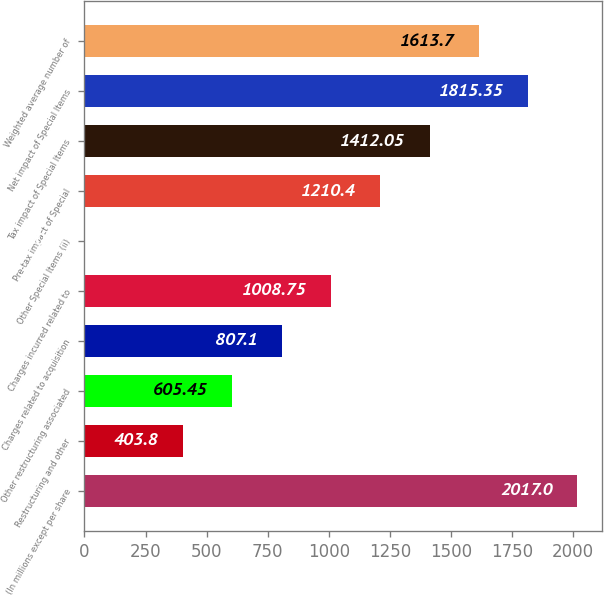Convert chart. <chart><loc_0><loc_0><loc_500><loc_500><bar_chart><fcel>(In millions except per share<fcel>Restructuring and other<fcel>Other restructuring associated<fcel>Charges related to acquisition<fcel>Charges incurred related to<fcel>Other Special Items (ii)<fcel>Pre-tax impact of Special<fcel>Tax impact of Special Items<fcel>Net impact of Special Items<fcel>Weighted average number of<nl><fcel>2017<fcel>403.8<fcel>605.45<fcel>807.1<fcel>1008.75<fcel>0.5<fcel>1210.4<fcel>1412.05<fcel>1815.35<fcel>1613.7<nl></chart> 